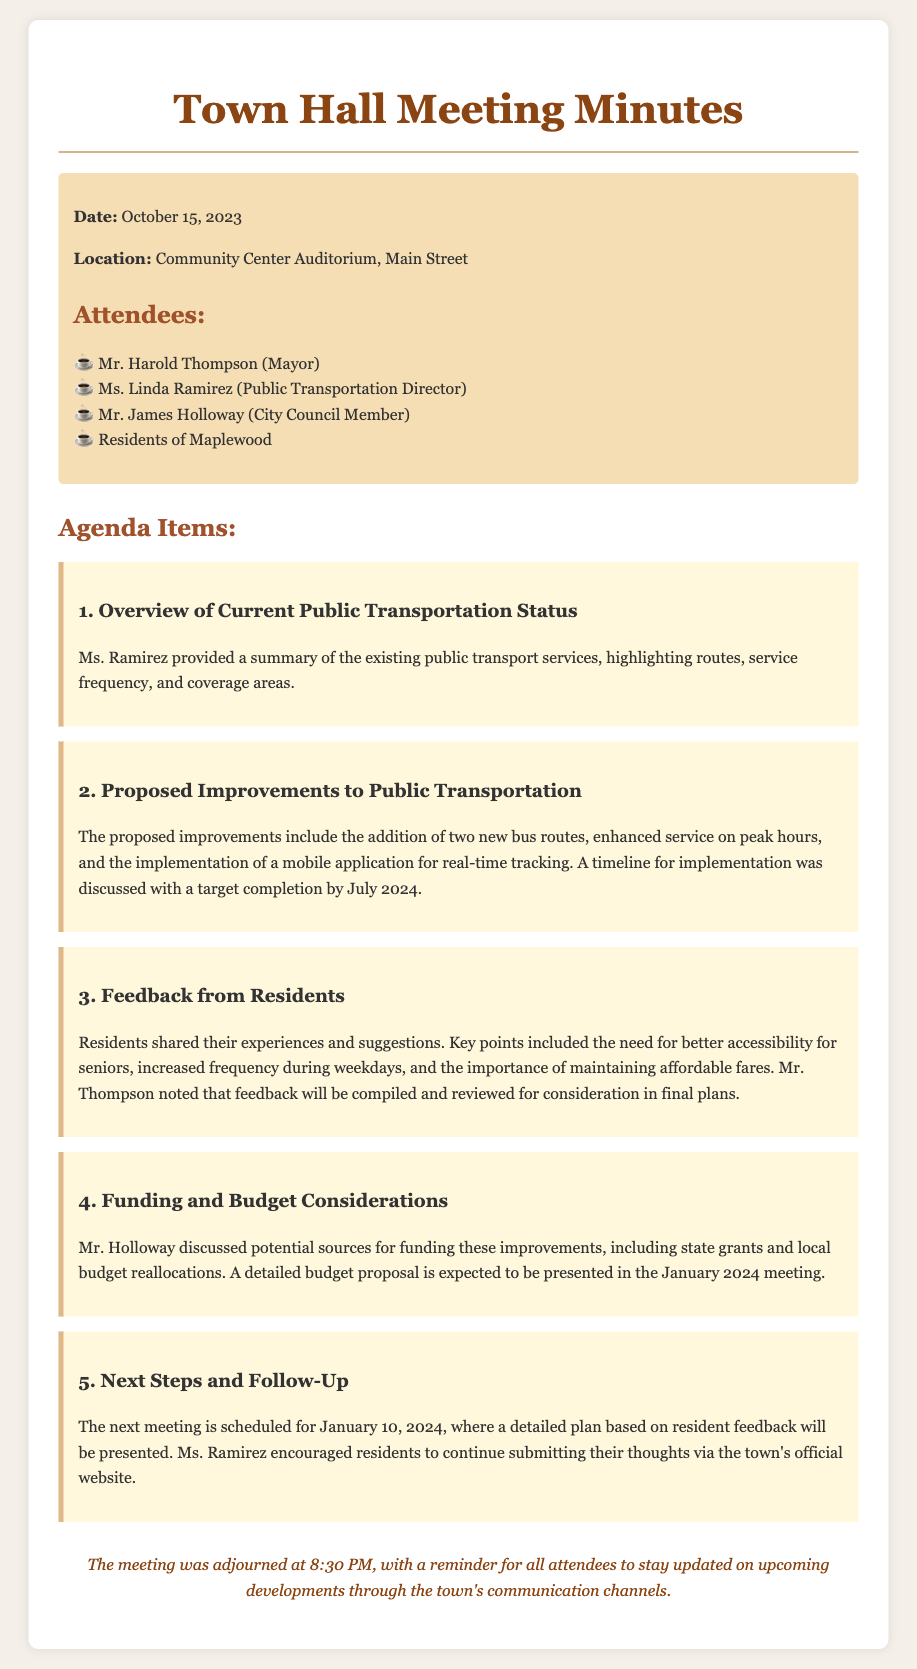What was the date of the meeting? The date of the meeting is mentioned in the document's introduction.
Answer: October 15, 2023 Who provided the overview of the current public transportation status? The document specifies who presented each agenda item.
Answer: Ms. Linda Ramirez What is the target completion date for the proposed improvements? The timeline for the proposed improvements is stated in the second agenda item.
Answer: July 2024 What did residents emphasize the need for during the feedback session? The key points from the residents during the feedback session highlight their suggestions.
Answer: Better accessibility for seniors When is the next meeting scheduled? The next meeting date is explicitly mentioned in the document.
Answer: January 10, 2024 What potential funding sources were discussed? The document lists funding considerations discussed during the meeting.
Answer: State grants and local budget reallocations What did Mr. Thompson note about the resident feedback? Mr. Thompson's comment on the feedback is outlined in the document.
Answer: Feedback will be compiled and reviewed What is the main agenda item focus of the meeting? The meeting minutes outline the primary focus of the agenda items discussed.
Answer: Public transportation improvements 